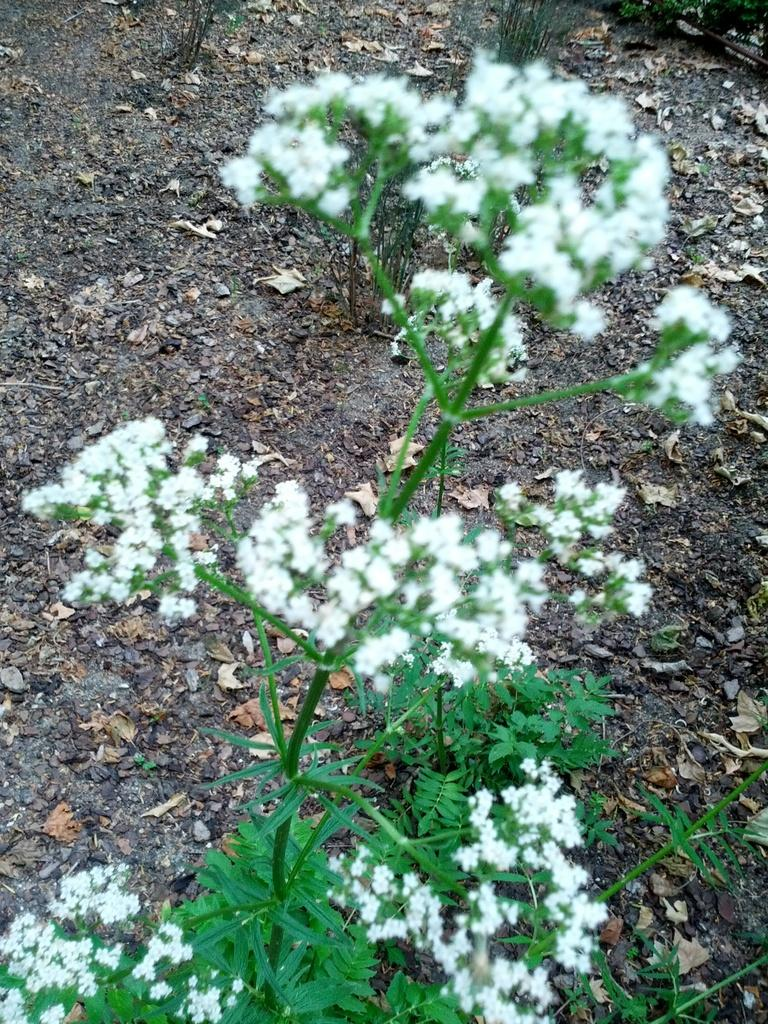What is the main subject of the picture? The main subject of the picture is a plant. What can be observed about the flowers on the plant? The plant has small white colorful flowers. What type of surface is under the plant? There is a mud surface under the plant. What else can be seen on the mud surface? Dried leaves are present on the mud surface. What type of cheese is visible on the plant in the image? There is no cheese present in the image; it features a plant with small white colorful flowers. How many cherries can be seen hanging from the plant in the image? There are no cherries present in the image; it features a plant with small white colorful flowers. 